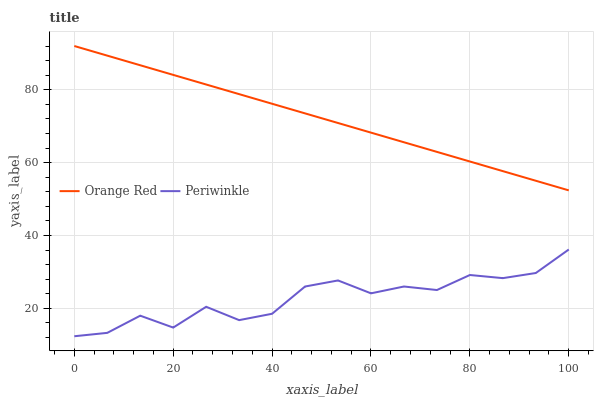Does Orange Red have the minimum area under the curve?
Answer yes or no. No. Is Orange Red the roughest?
Answer yes or no. No. Does Orange Red have the lowest value?
Answer yes or no. No. Is Periwinkle less than Orange Red?
Answer yes or no. Yes. Is Orange Red greater than Periwinkle?
Answer yes or no. Yes. Does Periwinkle intersect Orange Red?
Answer yes or no. No. 